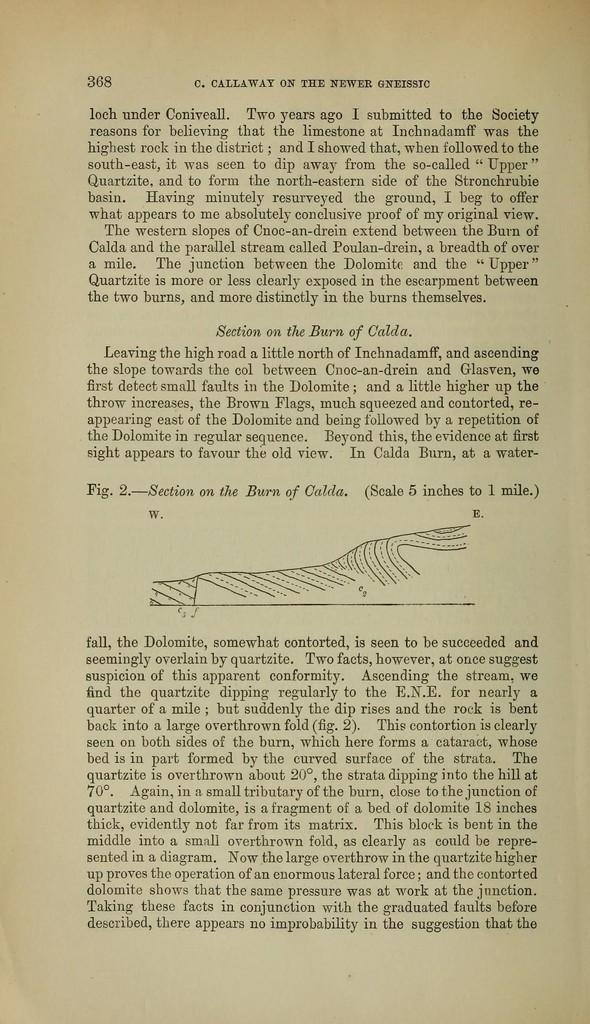<image>
Write a terse but informative summary of the picture. page 368 of c. callaway on the newer gneissic 